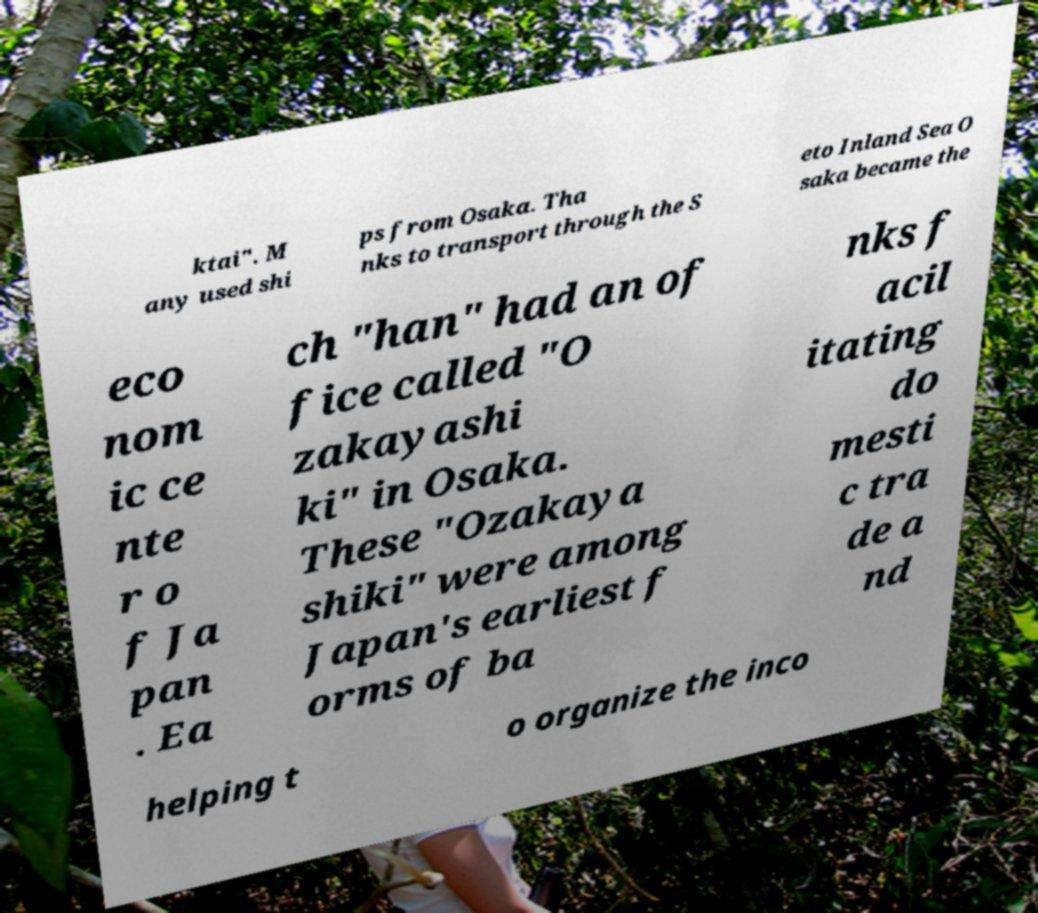Can you read and provide the text displayed in the image?This photo seems to have some interesting text. Can you extract and type it out for me? ktai". M any used shi ps from Osaka. Tha nks to transport through the S eto Inland Sea O saka became the eco nom ic ce nte r o f Ja pan . Ea ch "han" had an of fice called "O zakayashi ki" in Osaka. These "Ozakaya shiki" were among Japan's earliest f orms of ba nks f acil itating do mesti c tra de a nd helping t o organize the inco 